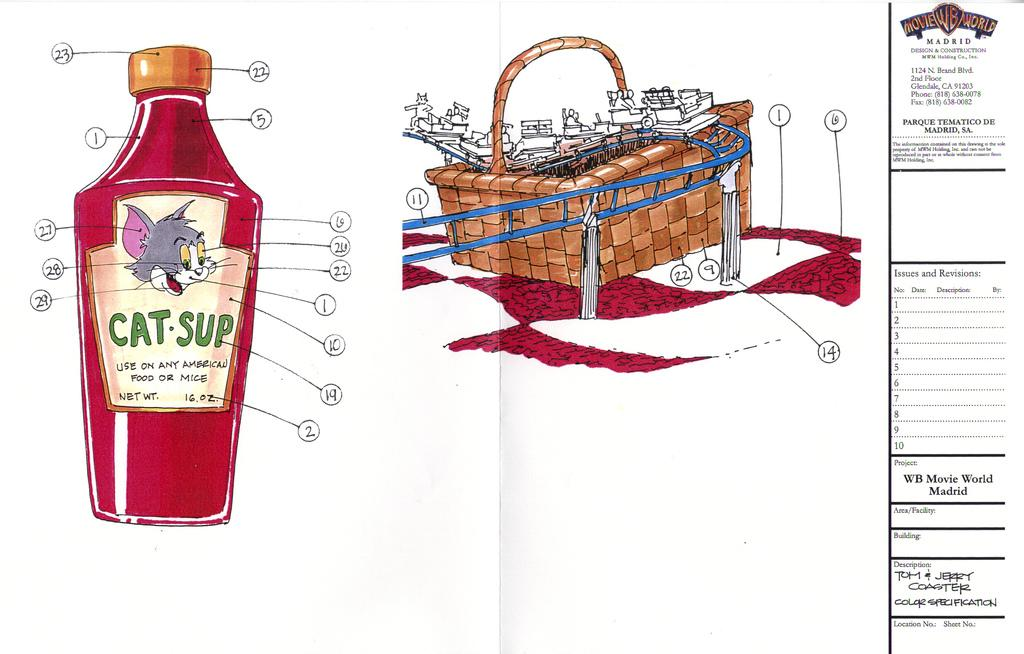<image>
Present a compact description of the photo's key features. A cartoon drawn bottle of "cat-sup" has Tom on the front. 